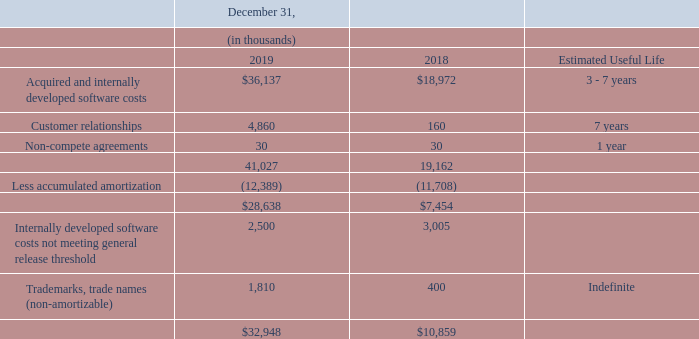Identifiable intangible assets
The Company's identifiable intangible assets represent intangible assets acquired in the Brink Acquisition, the Drive-Thru Acquisition, the Restaurant Magic Acquisition and software development costs. The Company capitalizes certain software development costs for software used in its Restaurant/Retail reporting segment. Software development costs incurred prior to establishing technological feasibility are charged to operations and included in research and development costs.
The technological feasibility of a software product is established when the Company has completed all planning, designing, coding, and testing activities that are necessary to establish that the software product meets its design specifications, including functionality, features, and technical performance requirements.
Software development costs incurred after establishing technological feasibility for software sold as a perpetual license, (as defined within ASC 985-20, Software – "Costs of Software to be sold, Leased, or Marketed" - for software cost related to sold as a perpetual license) are capitalized and amortized on a product-by-product basis when the software product is available for general release to customers.
Included in "Acquired and internally developed software costs" in the table below are approximately $2.5 million and $3.0 million of costs related to software products that have not satisfied the general release threshold as of December 31, 2019 and December 31, 2018, respectively. These software products are expected to satisfy the general release threshold within the next 12 months.
Software development is also capitalized in accordance with ASC 350-40, “Intangibles - Goodwill and Other - Internal - Use Software,” and is amortized over the expected benefit period, which generally ranges from three to seven years. Long-lived assets are tested for impairment when events or conditions indicate that the carrying value of an asset may not be fully recoverable from future cash flows. Software costs capitalized during the years ended 2019 and 2018 were $4.1 million and $3.9 million, respectively.
Annual amortization charged to cost of sales when a product is available for general release to customers is computed using the greater of (a) the straight-line method over the remaining estimated economic life of the product, generally three to seven years or (b) the ratio that current gross revenues for a product bear to the total of current and anticipated future gross revenues for that product. Amortization of capitalized software costs amounted to $3.3 million and $3.5 million, in 2019 and 2018, respectively.
The components of identifiable intangible assets, excluding discontinued operations, are:
How much was the amortization of capitalized software costs in 2019? $3.3 million. How much was the amortization of capitalized software costs in 2018? $3.5 million. How much was the Software costs capitalized during the years ended 2019 and 2018 respectively? $4.1 million, $3.9 million. What is the change in Acquired and internally developed software costs from December 31, 2018 and 2019?
Answer scale should be: thousand. 36,137-18,972
Answer: 17165. What is the change in accumulated amortization between December 31, 2018 and 2019?
Answer scale should be: thousand. 12,389-11,708
Answer: 681. What is the average Acquired and internally developed software costs for December 31, 2018 and 2019?
Answer scale should be: thousand. (36,137+18,972) / 2
Answer: 27554.5. 